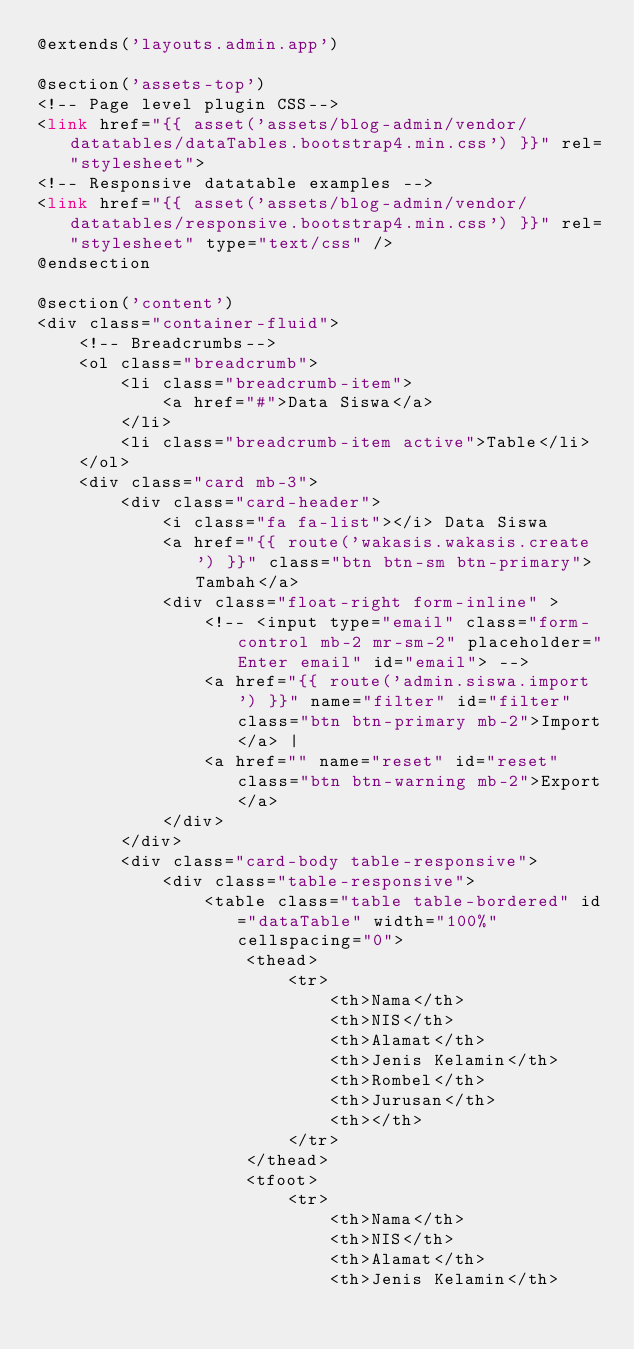<code> <loc_0><loc_0><loc_500><loc_500><_PHP_>@extends('layouts.admin.app')

@section('assets-top')
<!-- Page level plugin CSS-->
<link href="{{ asset('assets/blog-admin/vendor/datatables/dataTables.bootstrap4.min.css') }}" rel="stylesheet">
<!-- Responsive datatable examples -->
<link href="{{ asset('assets/blog-admin/vendor/datatables/responsive.bootstrap4.min.css') }}" rel="stylesheet" type="text/css" />
@endsection

@section('content')
<div class="container-fluid">
    <!-- Breadcrumbs--> 
    <ol class="breadcrumb">
        <li class="breadcrumb-item">
            <a href="#">Data Siswa</a>
        </li>
        <li class="breadcrumb-item active">Table</li>
    </ol>
    <div class="card mb-3">
        <div class="card-header">
            <i class="fa fa-list"></i> Data Siswa
            <a href="{{ route('wakasis.wakasis.create') }}" class="btn btn-sm btn-primary">Tambah</a>
            <div class="float-right form-inline" >
                <!-- <input type="email" class="form-control mb-2 mr-sm-2" placeholder="Enter email" id="email"> -->
                <a href="{{ route('admin.siswa.import') }}" name="filter" id="filter" class="btn btn-primary mb-2">Import</a> | 
                <a href="" name="reset" id="reset" class="btn btn-warning mb-2">Export</a>
            </div>
        </div>
        <div class="card-body table-responsive">
            <div class="table-responsive">
                <table class="table table-bordered" id="dataTable" width="100%" cellspacing="0">
                    <thead>
                        <tr>
                            <th>Nama</th>
                            <th>NIS</th>
                            <th>Alamat</th>
                            <th>Jenis Kelamin</th>
                            <th>Rombel</th>
                            <th>Jurusan</th>
                            <th></th>
                        </tr>
                    </thead>
                    <tfoot>
                        <tr>
                            <th>Nama</th>
                            <th>NIS</th>
                            <th>Alamat</th>
                            <th>Jenis Kelamin</th></code> 